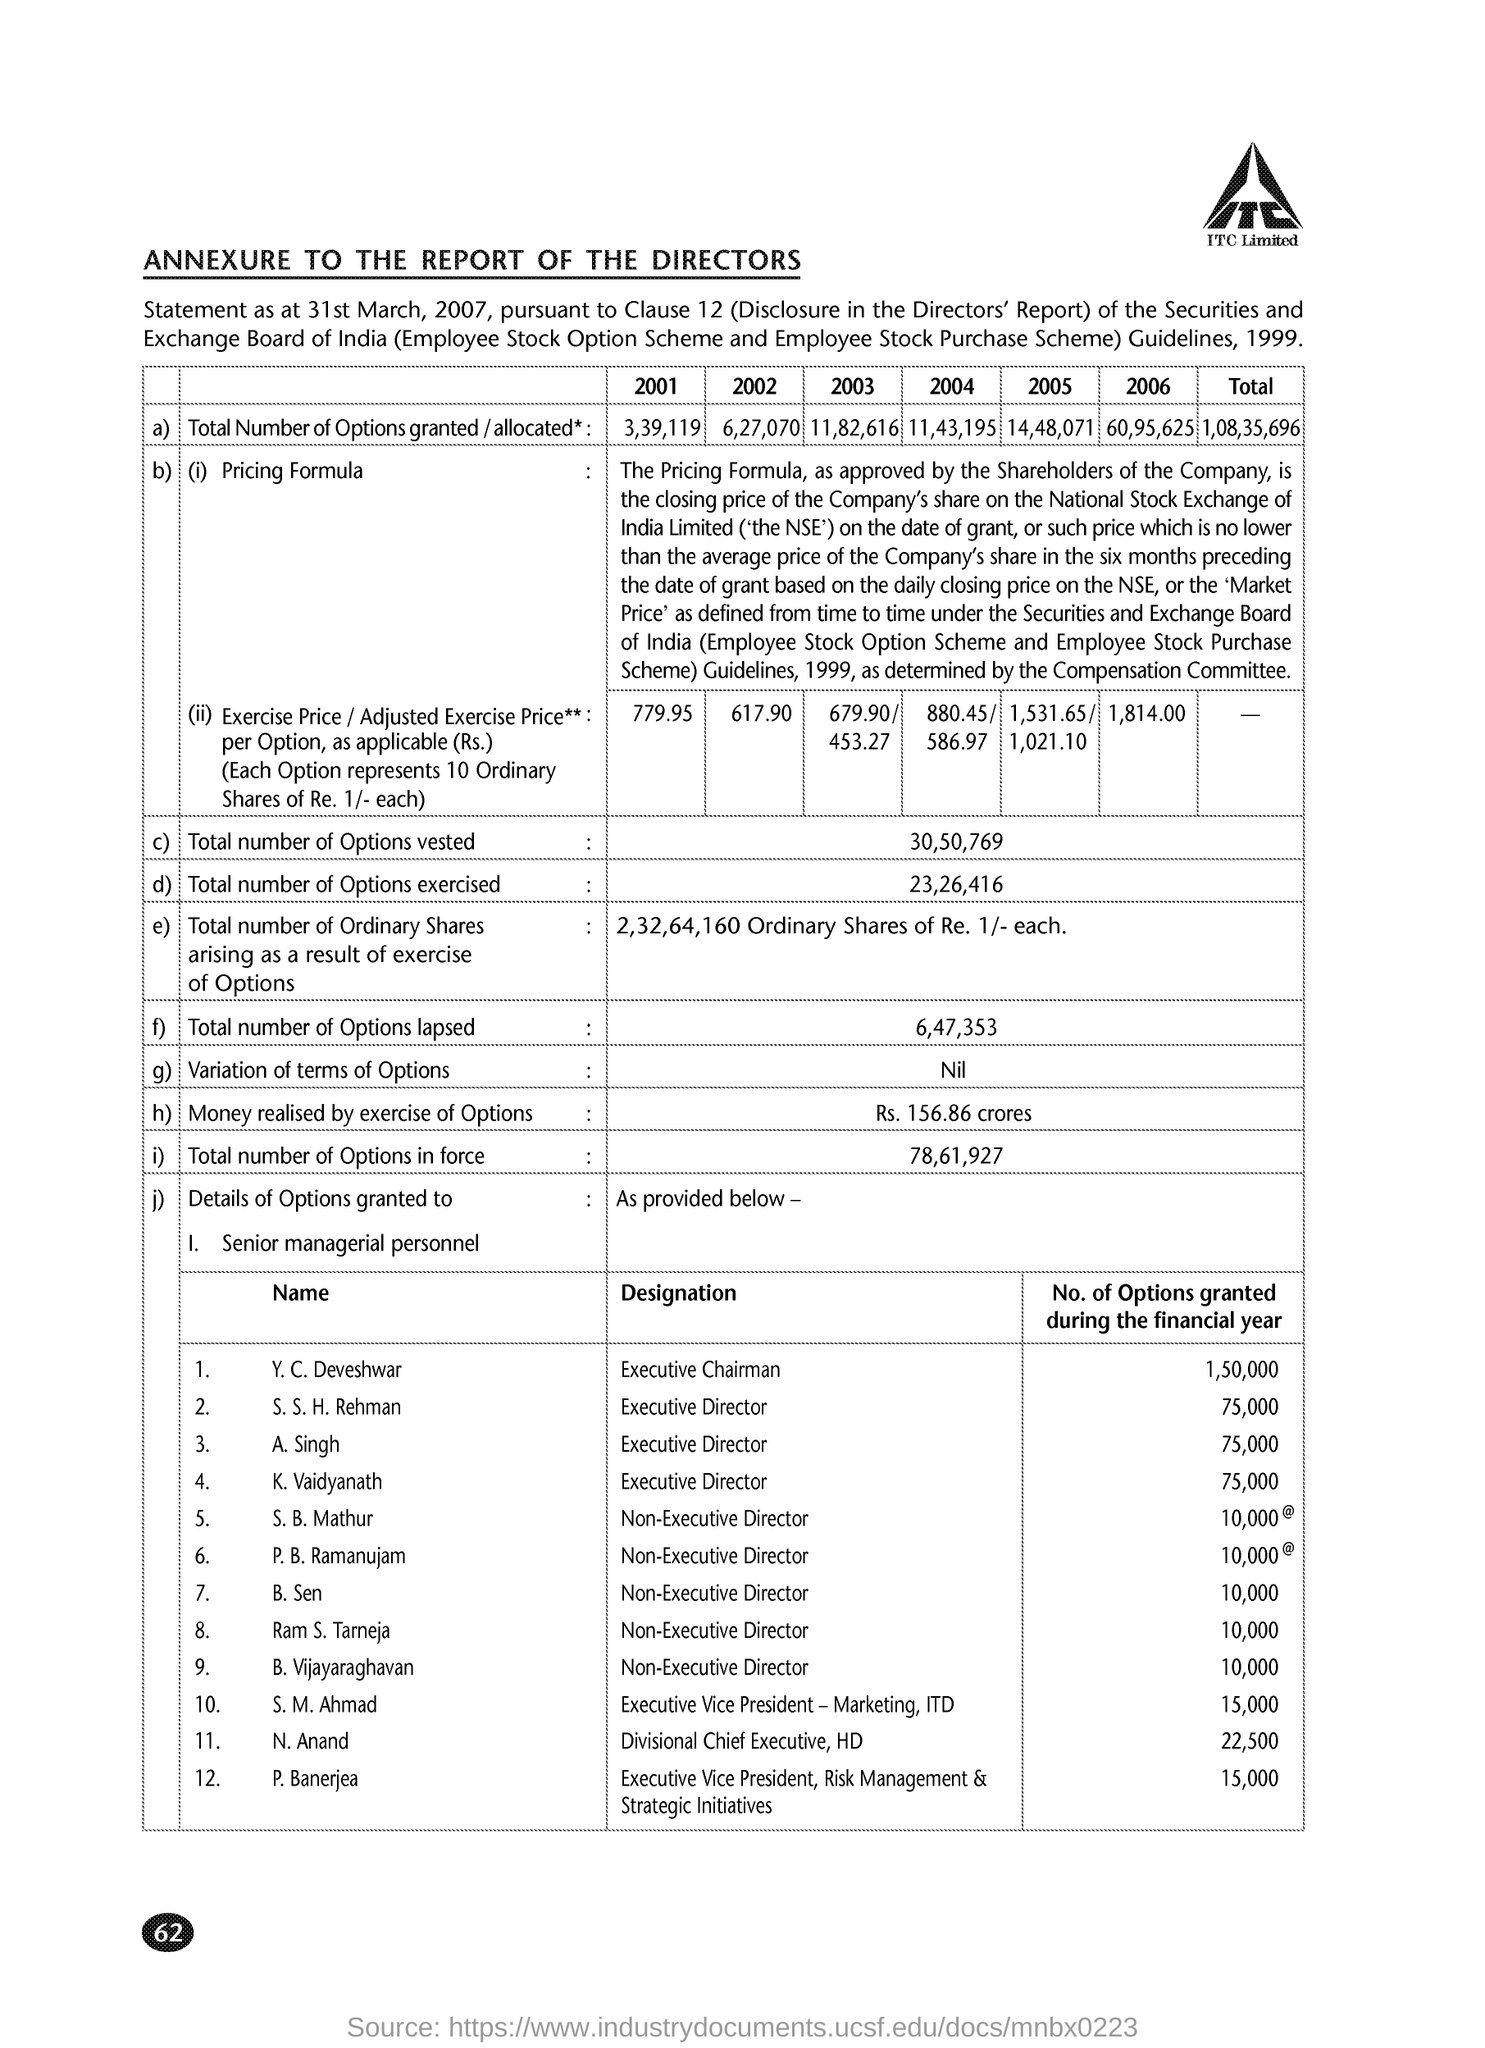What is the Total number of Options vested?
Your answer should be compact. 30,50,769. What is the Total number of Options exercised?
Offer a very short reply. 23,26,416. What is the Total number of Options lapsed?
Your response must be concise. 6,47,353. What is the Total number of Options in force?
Give a very brief answer. 78,61,927. What are the No. of Options granted during the financial year for Y. C. Deveshwar?
Provide a short and direct response. 1,50,000. What are the No. of Options granted during the financial year for A. Singh?
Provide a short and direct response. 75,000. What are the No. of Options granted during the financial year for K. Vaidyanath?
Your answer should be compact. 75,000. What are the No. of Options granted during the financial year for B. Sen?
Ensure brevity in your answer.  10,000. What are the No. of Options granted during the financial year for N. Anand?
Provide a short and direct response. 22,500. What are the No. of Options granted during the financial year for S. B. Mathur?
Your answer should be very brief. 10,000. 